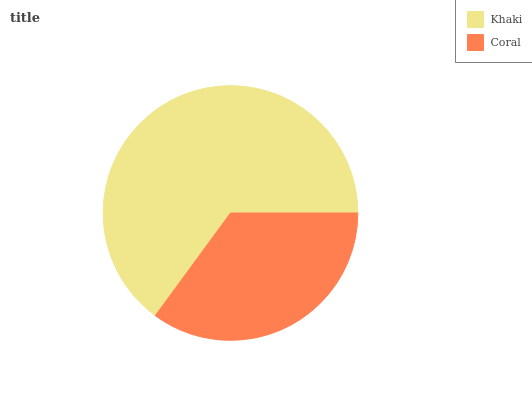Is Coral the minimum?
Answer yes or no. Yes. Is Khaki the maximum?
Answer yes or no. Yes. Is Coral the maximum?
Answer yes or no. No. Is Khaki greater than Coral?
Answer yes or no. Yes. Is Coral less than Khaki?
Answer yes or no. Yes. Is Coral greater than Khaki?
Answer yes or no. No. Is Khaki less than Coral?
Answer yes or no. No. Is Khaki the high median?
Answer yes or no. Yes. Is Coral the low median?
Answer yes or no. Yes. Is Coral the high median?
Answer yes or no. No. Is Khaki the low median?
Answer yes or no. No. 